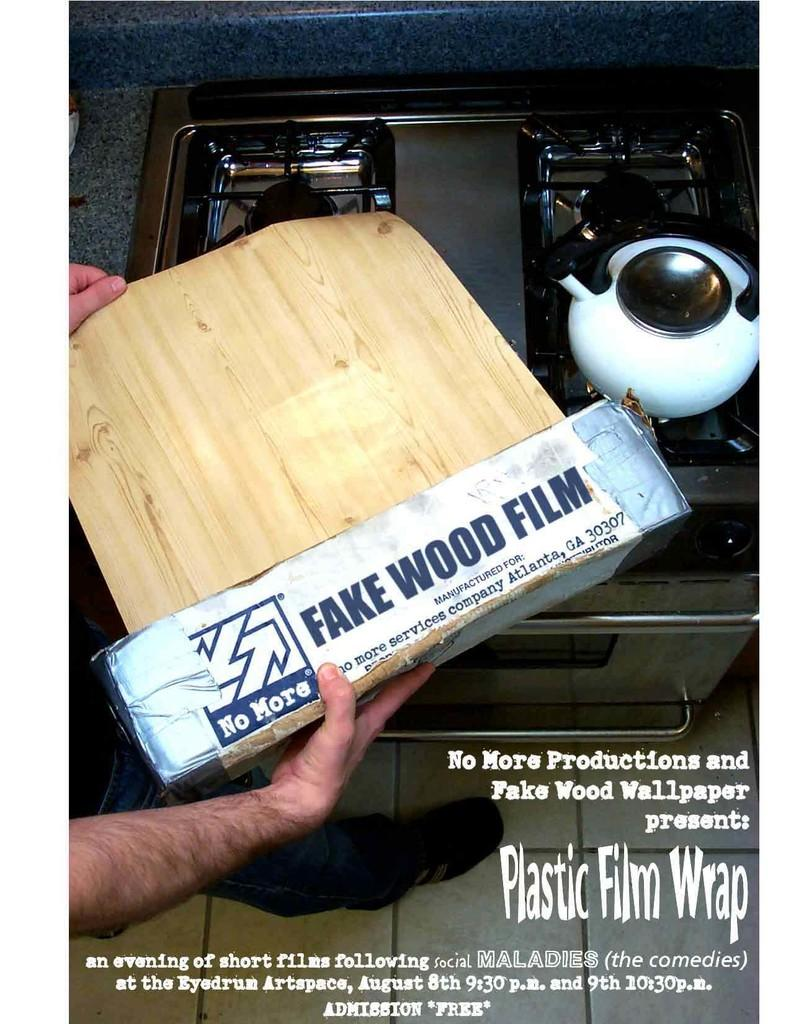What type of appliance can be seen in the image? There is a stove in the image. What is placed on the stove? There is a teapot in the image. Can you describe the person in the image? There is a person standing in the image. What is the appearance of the background in the image? The image has a fake wood film. What is written at the bottom of the image? There is text at the bottom of the image. What type of medical advice does the doctor provide in the image? There is no doctor present in the image, so no medical advice can be provided. What type of attraction is depicted in the image? There is no attraction depicted in the image; it features a stove, a teapot, a person, and text. 